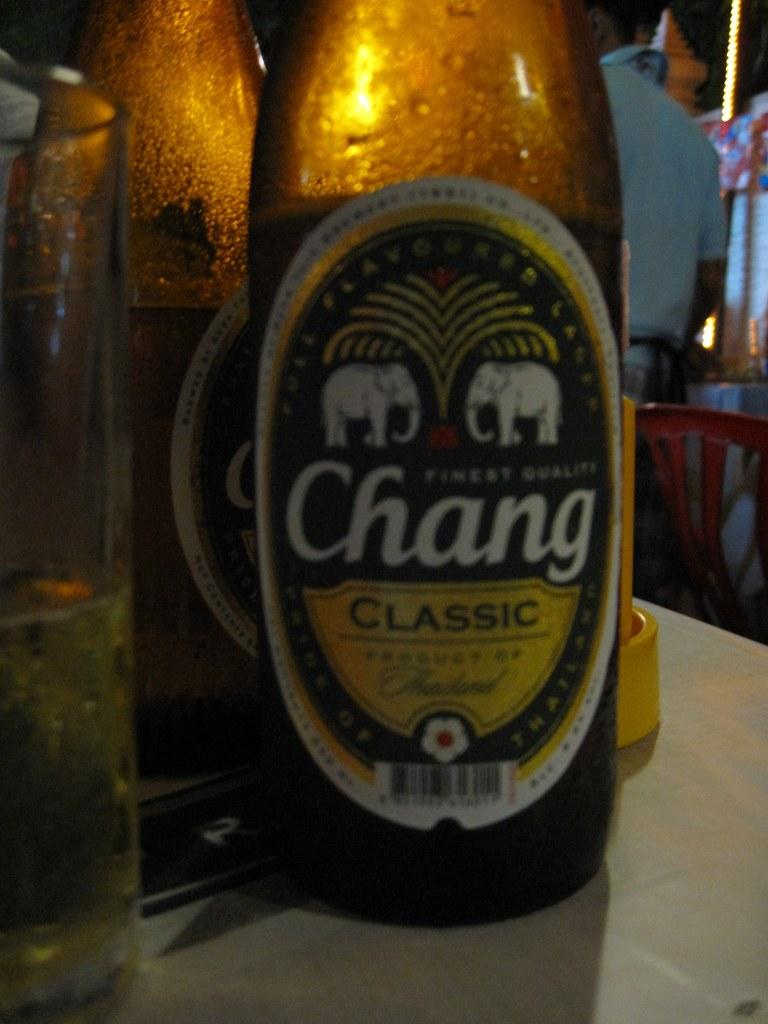What type of beverage is featured in the image? There are wine bottles and a glass of wine in the image. Where are the wine bottles and glass of wine located? They are on a table in the image. What can be seen in the background of the image? There is a chair and some other objects in the background of the image. What type of plants can be seen growing on the map in the image? There is no map or plants present in the image. Can you hear the bells ringing in the image? There is no mention of bells or any sound in the image. 